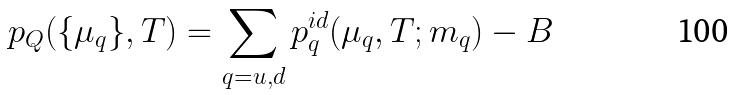Convert formula to latex. <formula><loc_0><loc_0><loc_500><loc_500>p _ { Q } ( \{ \mu _ { q } \} , T ) = \sum _ { q = u , d } p ^ { i d } _ { q } ( \mu _ { q } , T ; m _ { q } ) - B</formula> 